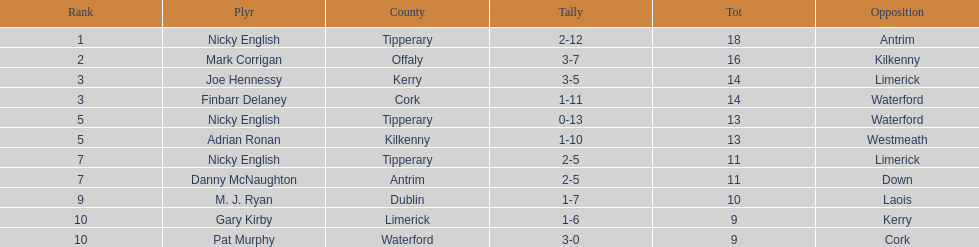Which player ranked the most? Nicky English. 